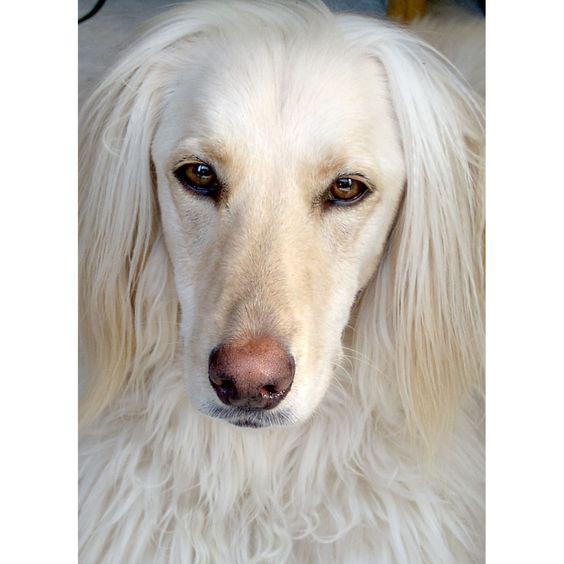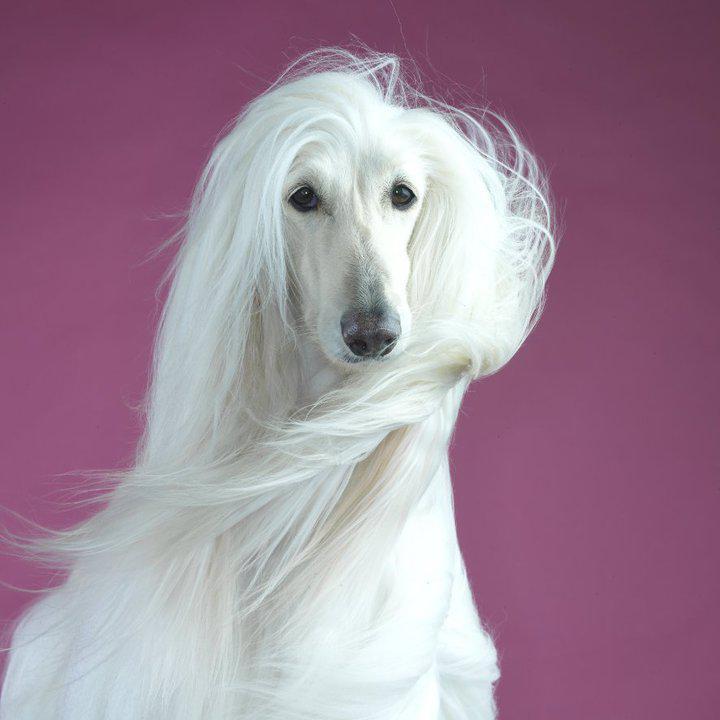The first image is the image on the left, the second image is the image on the right. Evaluate the accuracy of this statement regarding the images: "The dog in the image on the right has a white coat.". Is it true? Answer yes or no. Yes. 